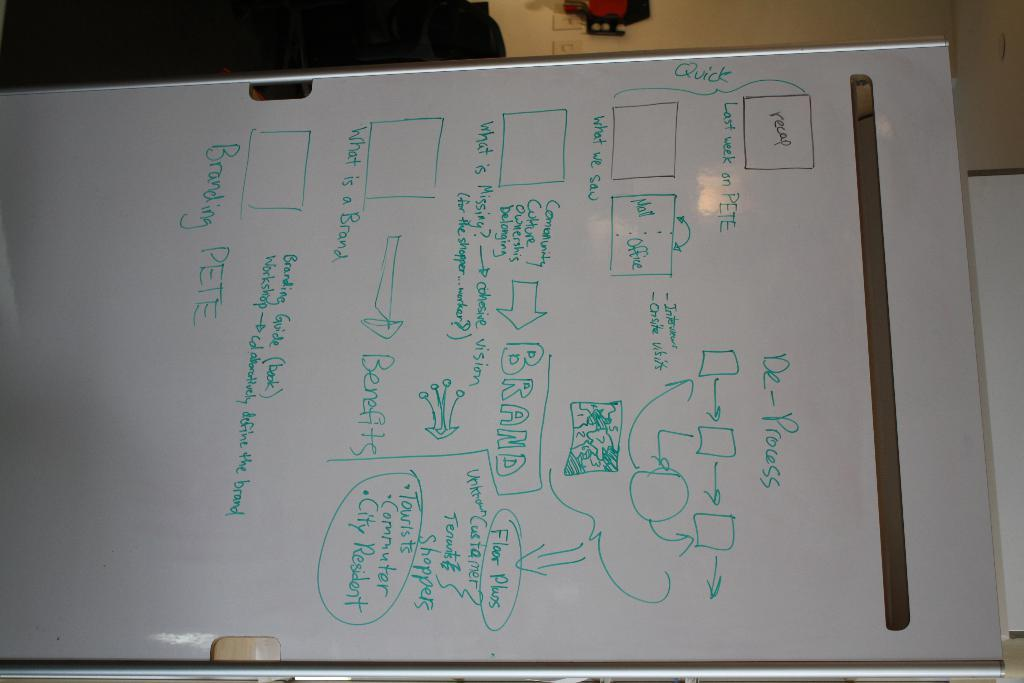What is the main subject of the image? The main subject of the image is a whiteboard. What can be seen on the whiteboard? There are letters and diagrams on the whiteboard. What is visible in the background of the image? There is a wall in the background of the image. What type of brass instrument is being played in the image? There is no brass instrument or any indication of music being played in the image; it is a whiteboard with letters and diagrams. What color is the underwear being worn by the person in the image? There is no person or any clothing visible in the image; it is a whiteboard with letters and diagrams on it. 